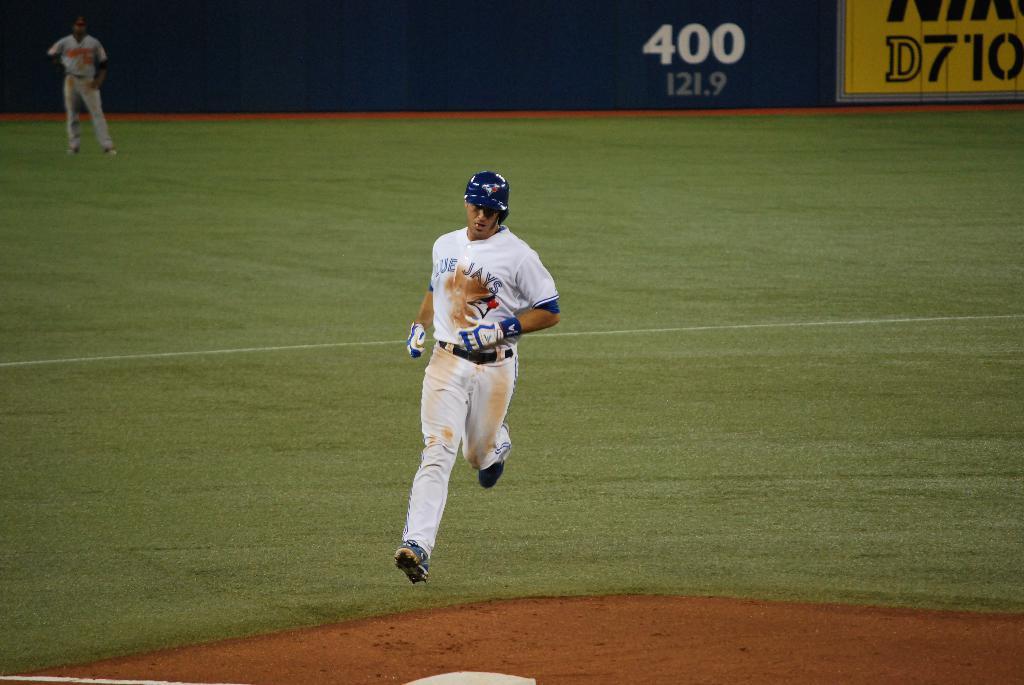What are the 3 numbers after the letter d?
Make the answer very short. 710. 